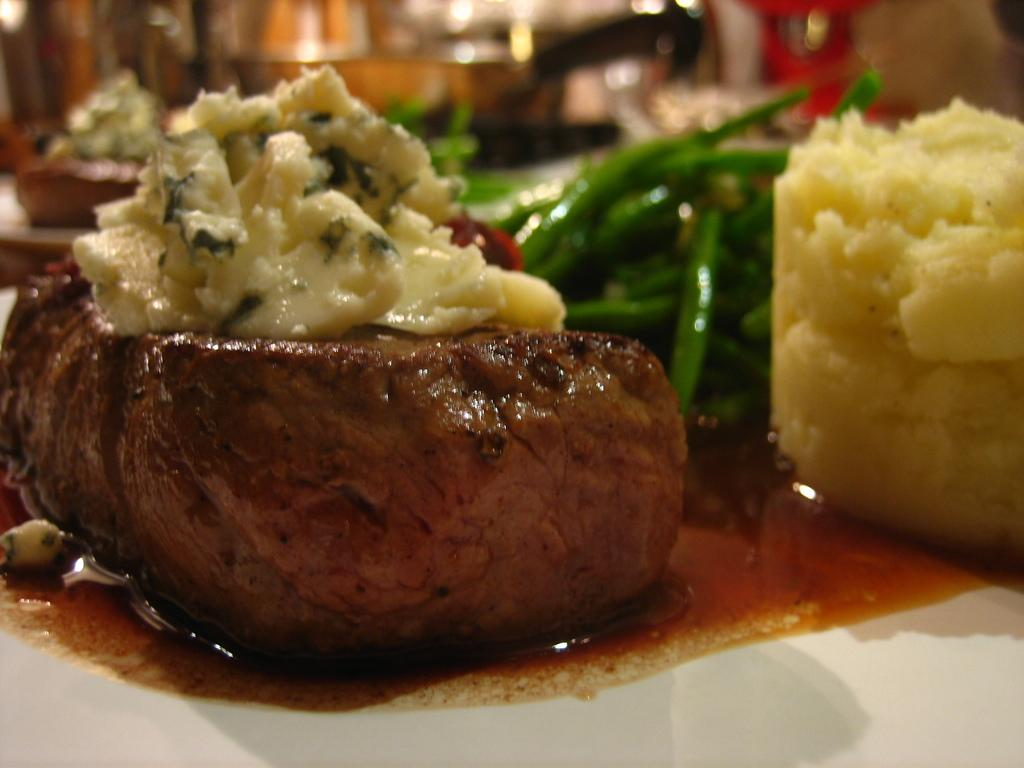What is located at the bottom of the image? There is a plate at the bottom of the image. What is on the plate? There is food on the plate. What else can be seen behind the plate? There are glasses behind the plate. Can you describe the background of the image? The background of the image is blurred. Where is the friend sitting in the lunchroom in the image? There is no friend or lunchroom present in the image. 